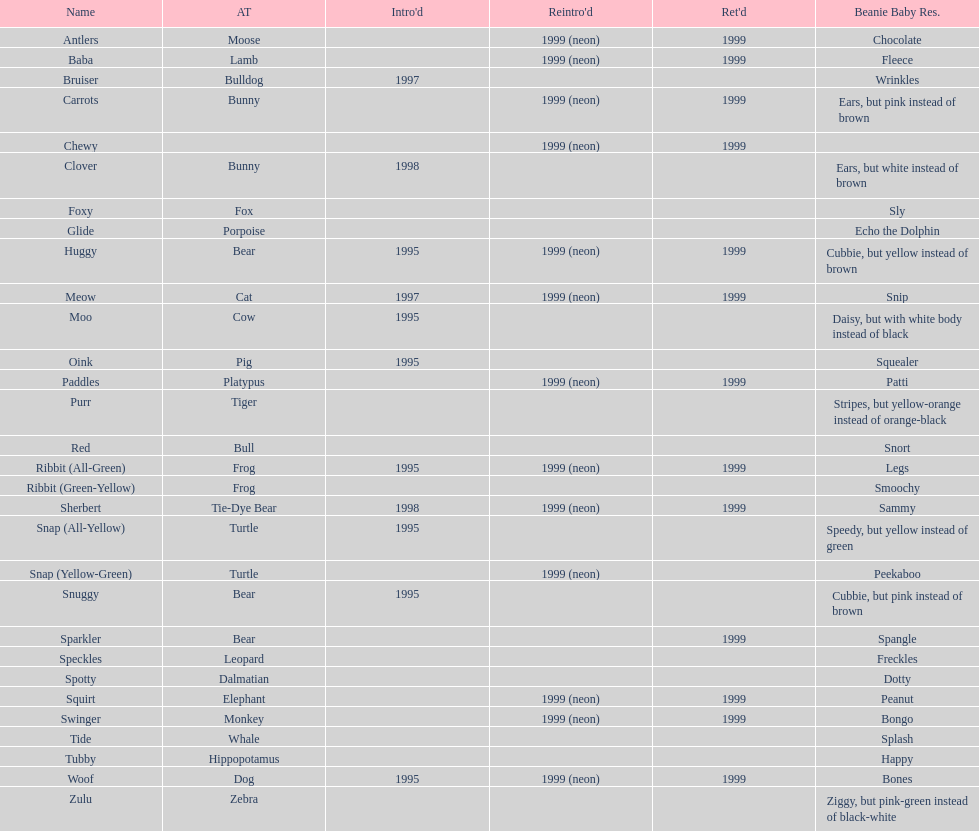How many monkey pillow pals were there? 1. Would you be able to parse every entry in this table? {'header': ['Name', 'AT', "Intro'd", "Reintro'd", "Ret'd", 'Beanie Baby Res.'], 'rows': [['Antlers', 'Moose', '', '1999 (neon)', '1999', 'Chocolate'], ['Baba', 'Lamb', '', '1999 (neon)', '1999', 'Fleece'], ['Bruiser', 'Bulldog', '1997', '', '', 'Wrinkles'], ['Carrots', 'Bunny', '', '1999 (neon)', '1999', 'Ears, but pink instead of brown'], ['Chewy', '', '', '1999 (neon)', '1999', ''], ['Clover', 'Bunny', '1998', '', '', 'Ears, but white instead of brown'], ['Foxy', 'Fox', '', '', '', 'Sly'], ['Glide', 'Porpoise', '', '', '', 'Echo the Dolphin'], ['Huggy', 'Bear', '1995', '1999 (neon)', '1999', 'Cubbie, but yellow instead of brown'], ['Meow', 'Cat', '1997', '1999 (neon)', '1999', 'Snip'], ['Moo', 'Cow', '1995', '', '', 'Daisy, but with white body instead of black'], ['Oink', 'Pig', '1995', '', '', 'Squealer'], ['Paddles', 'Platypus', '', '1999 (neon)', '1999', 'Patti'], ['Purr', 'Tiger', '', '', '', 'Stripes, but yellow-orange instead of orange-black'], ['Red', 'Bull', '', '', '', 'Snort'], ['Ribbit (All-Green)', 'Frog', '1995', '1999 (neon)', '1999', 'Legs'], ['Ribbit (Green-Yellow)', 'Frog', '', '', '', 'Smoochy'], ['Sherbert', 'Tie-Dye Bear', '1998', '1999 (neon)', '1999', 'Sammy'], ['Snap (All-Yellow)', 'Turtle', '1995', '', '', 'Speedy, but yellow instead of green'], ['Snap (Yellow-Green)', 'Turtle', '', '1999 (neon)', '', 'Peekaboo'], ['Snuggy', 'Bear', '1995', '', '', 'Cubbie, but pink instead of brown'], ['Sparkler', 'Bear', '', '', '1999', 'Spangle'], ['Speckles', 'Leopard', '', '', '', 'Freckles'], ['Spotty', 'Dalmatian', '', '', '', 'Dotty'], ['Squirt', 'Elephant', '', '1999 (neon)', '1999', 'Peanut'], ['Swinger', 'Monkey', '', '1999 (neon)', '1999', 'Bongo'], ['Tide', 'Whale', '', '', '', 'Splash'], ['Tubby', 'Hippopotamus', '', '', '', 'Happy'], ['Woof', 'Dog', '1995', '1999 (neon)', '1999', 'Bones'], ['Zulu', 'Zebra', '', '', '', 'Ziggy, but pink-green instead of black-white']]} 